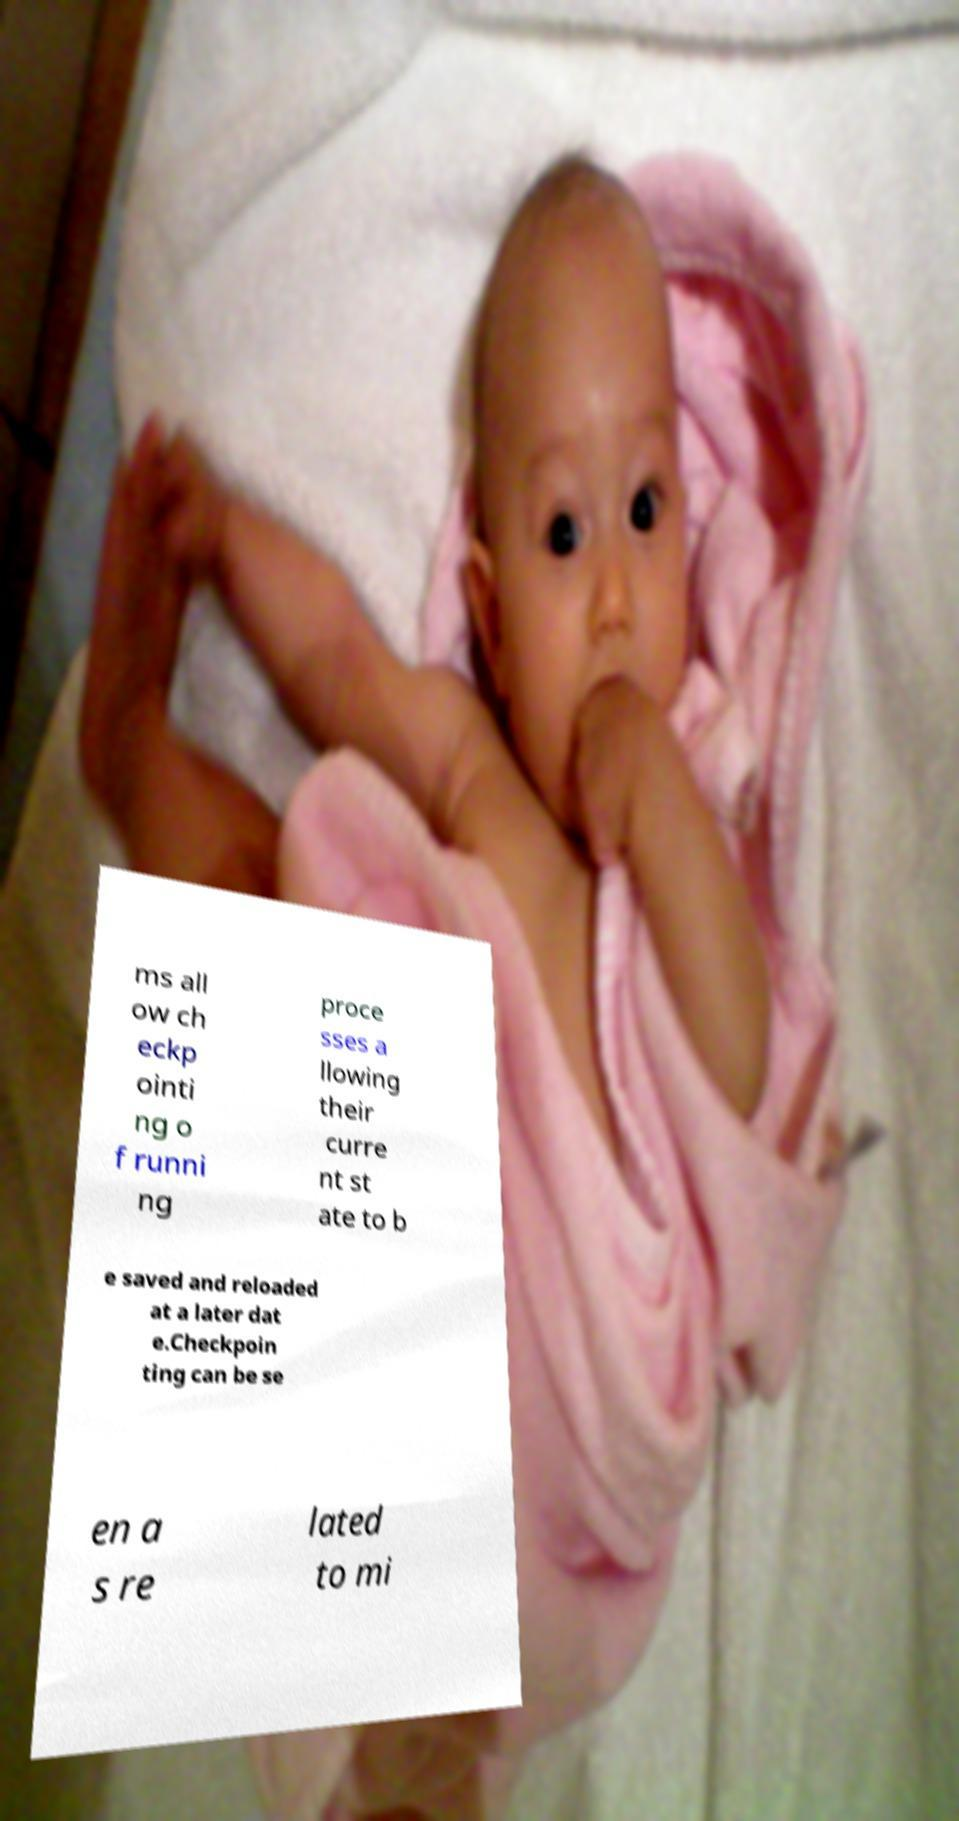What messages or text are displayed in this image? I need them in a readable, typed format. ms all ow ch eckp ointi ng o f runni ng proce sses a llowing their curre nt st ate to b e saved and reloaded at a later dat e.Checkpoin ting can be se en a s re lated to mi 